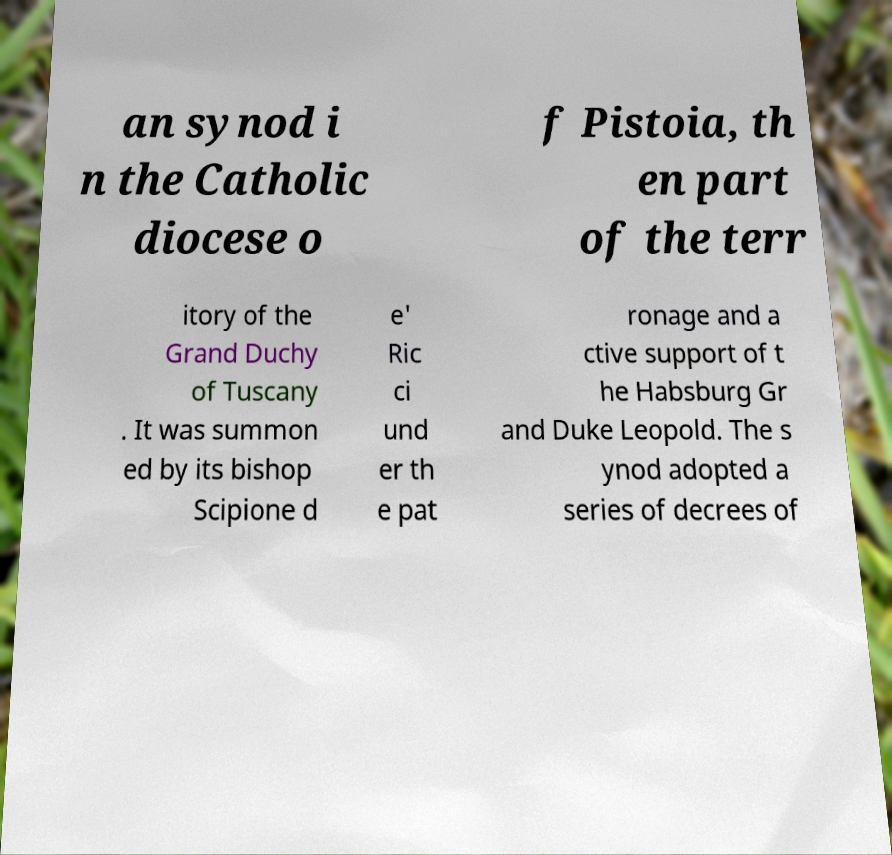Please identify and transcribe the text found in this image. an synod i n the Catholic diocese o f Pistoia, th en part of the terr itory of the Grand Duchy of Tuscany . It was summon ed by its bishop Scipione d e' Ric ci und er th e pat ronage and a ctive support of t he Habsburg Gr and Duke Leopold. The s ynod adopted a series of decrees of 